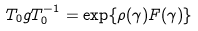Convert formula to latex. <formula><loc_0><loc_0><loc_500><loc_500>T _ { 0 } g T _ { 0 } ^ { - 1 } = \exp \{ \rho ( \gamma ) F ( \gamma ) \}</formula> 